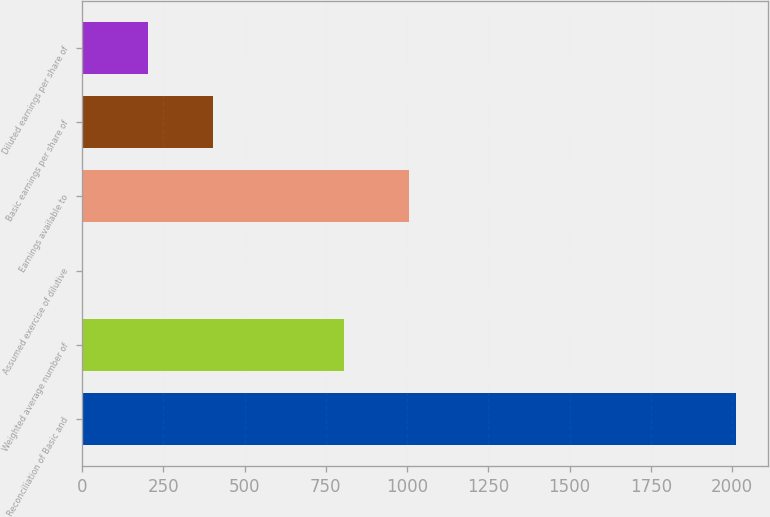Convert chart to OTSL. <chart><loc_0><loc_0><loc_500><loc_500><bar_chart><fcel>Reconciliation of Basic and<fcel>Weighted average number of<fcel>Assumed exercise of dilutive<fcel>Earnings available to<fcel>Basic earnings per share of<fcel>Diluted earnings per share of<nl><fcel>2011<fcel>805.6<fcel>2<fcel>1006.5<fcel>403.8<fcel>202.9<nl></chart> 